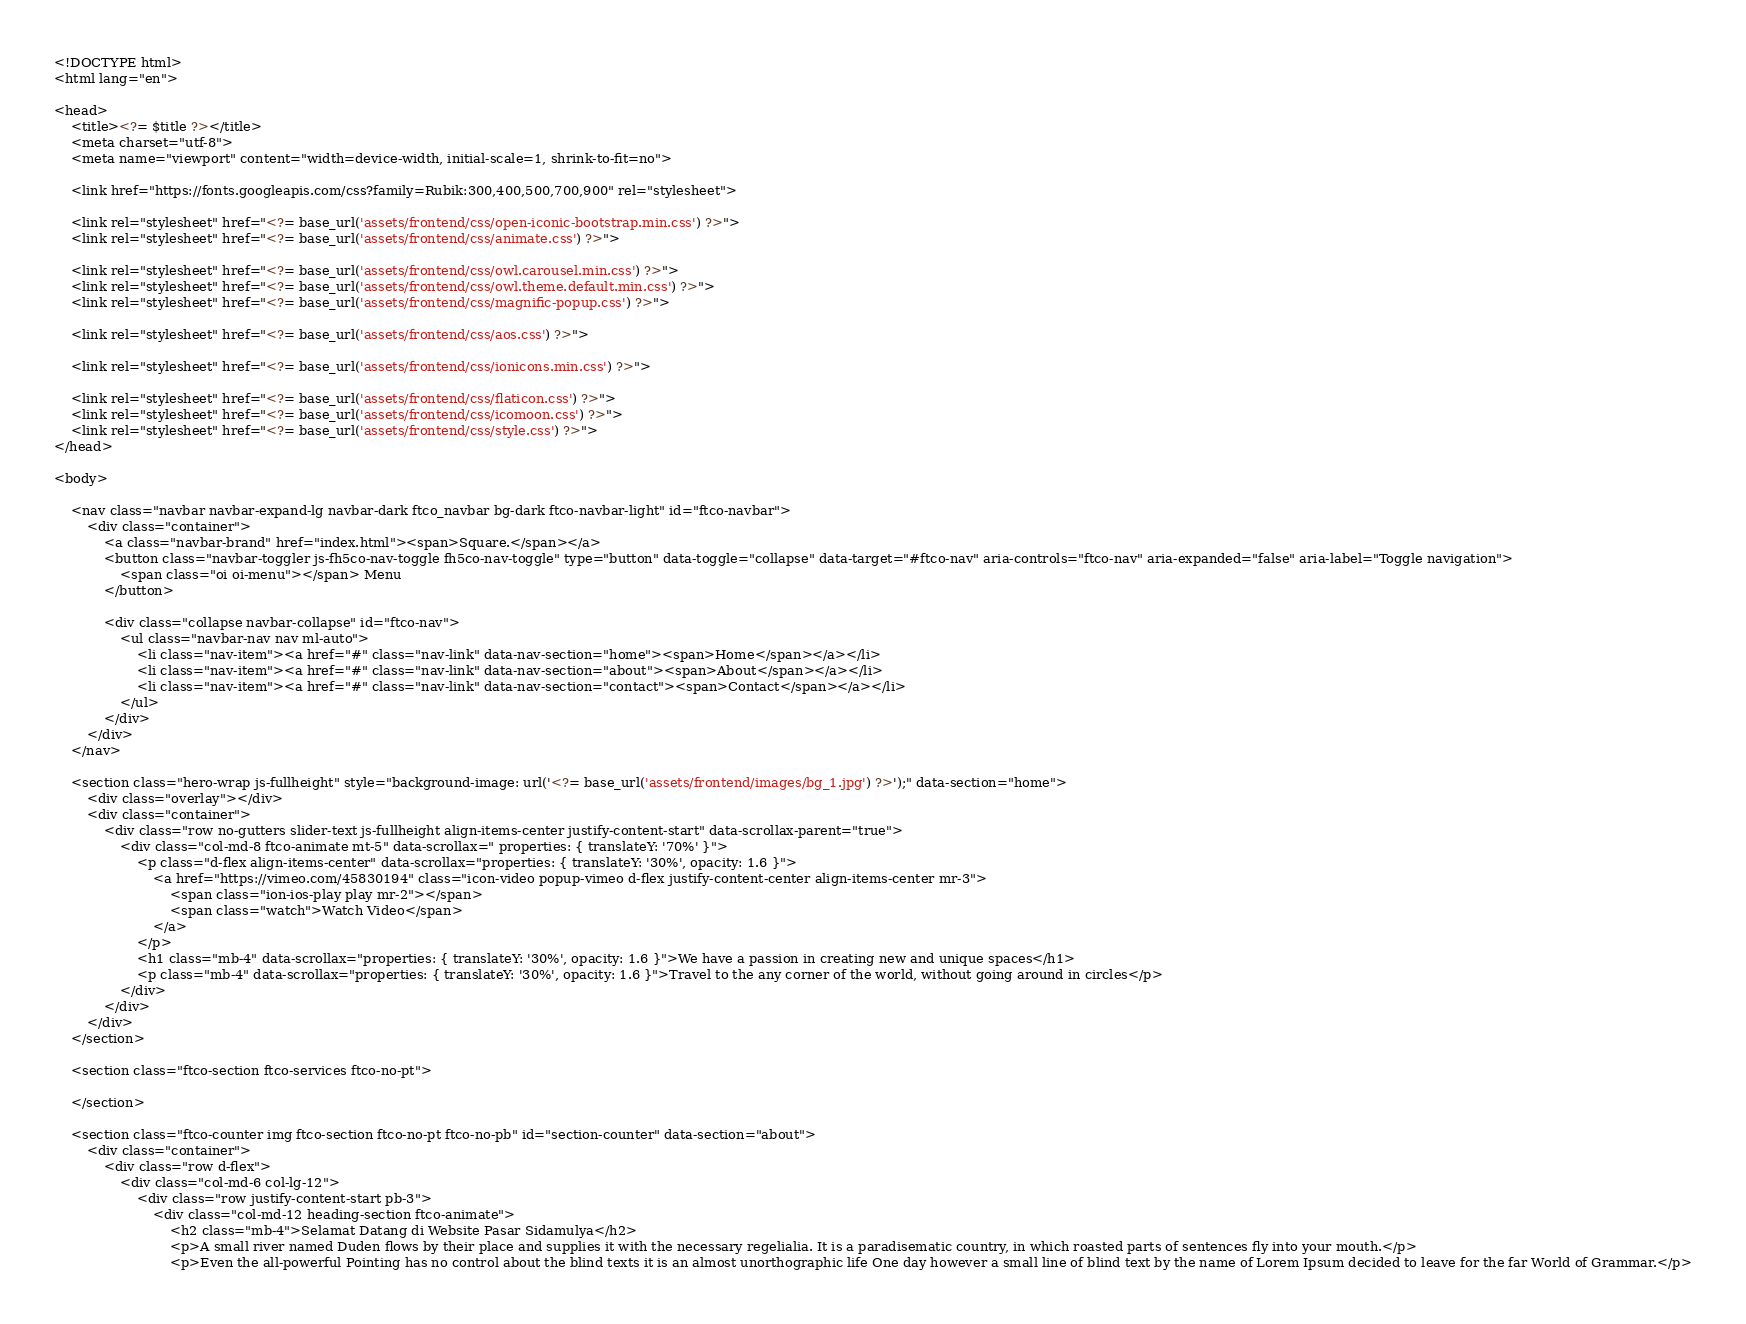Convert code to text. <code><loc_0><loc_0><loc_500><loc_500><_PHP_><!DOCTYPE html>
<html lang="en">

<head>
	<title><?= $title ?></title>
	<meta charset="utf-8">
	<meta name="viewport" content="width=device-width, initial-scale=1, shrink-to-fit=no">

	<link href="https://fonts.googleapis.com/css?family=Rubik:300,400,500,700,900" rel="stylesheet">

	<link rel="stylesheet" href="<?= base_url('assets/frontend/css/open-iconic-bootstrap.min.css') ?>">
	<link rel="stylesheet" href="<?= base_url('assets/frontend/css/animate.css') ?>">

	<link rel="stylesheet" href="<?= base_url('assets/frontend/css/owl.carousel.min.css') ?>">
	<link rel="stylesheet" href="<?= base_url('assets/frontend/css/owl.theme.default.min.css') ?>">
	<link rel="stylesheet" href="<?= base_url('assets/frontend/css/magnific-popup.css') ?>">

	<link rel="stylesheet" href="<?= base_url('assets/frontend/css/aos.css') ?>">

	<link rel="stylesheet" href="<?= base_url('assets/frontend/css/ionicons.min.css') ?>">

	<link rel="stylesheet" href="<?= base_url('assets/frontend/css/flaticon.css') ?>">
	<link rel="stylesheet" href="<?= base_url('assets/frontend/css/icomoon.css') ?>">
	<link rel="stylesheet" href="<?= base_url('assets/frontend/css/style.css') ?>">
</head>

<body>

	<nav class="navbar navbar-expand-lg navbar-dark ftco_navbar bg-dark ftco-navbar-light" id="ftco-navbar">
		<div class="container">
			<a class="navbar-brand" href="index.html"><span>Square.</span></a>
			<button class="navbar-toggler js-fh5co-nav-toggle fh5co-nav-toggle" type="button" data-toggle="collapse" data-target="#ftco-nav" aria-controls="ftco-nav" aria-expanded="false" aria-label="Toggle navigation">
				<span class="oi oi-menu"></span> Menu
			</button>

			<div class="collapse navbar-collapse" id="ftco-nav">
				<ul class="navbar-nav nav ml-auto">
					<li class="nav-item"><a href="#" class="nav-link" data-nav-section="home"><span>Home</span></a></li>
					<li class="nav-item"><a href="#" class="nav-link" data-nav-section="about"><span>About</span></a></li>
					<li class="nav-item"><a href="#" class="nav-link" data-nav-section="contact"><span>Contact</span></a></li>
				</ul>
			</div>
		</div>
	</nav>

	<section class="hero-wrap js-fullheight" style="background-image: url('<?= base_url('assets/frontend/images/bg_1.jpg') ?>');" data-section="home">
		<div class="overlay"></div>
		<div class="container">
			<div class="row no-gutters slider-text js-fullheight align-items-center justify-content-start" data-scrollax-parent="true">
				<div class="col-md-8 ftco-animate mt-5" data-scrollax=" properties: { translateY: '70%' }">
					<p class="d-flex align-items-center" data-scrollax="properties: { translateY: '30%', opacity: 1.6 }">
						<a href="https://vimeo.com/45830194" class="icon-video popup-vimeo d-flex justify-content-center align-items-center mr-3">
							<span class="ion-ios-play play mr-2"></span>
							<span class="watch">Watch Video</span>
						</a>
					</p>
					<h1 class="mb-4" data-scrollax="properties: { translateY: '30%', opacity: 1.6 }">We have a passion in creating new and unique spaces</h1>
					<p class="mb-4" data-scrollax="properties: { translateY: '30%', opacity: 1.6 }">Travel to the any corner of the world, without going around in circles</p>
				</div>
			</div>
		</div>
	</section>

	<section class="ftco-section ftco-services ftco-no-pt">

	</section>

	<section class="ftco-counter img ftco-section ftco-no-pt ftco-no-pb" id="section-counter" data-section="about">
		<div class="container">
			<div class="row d-flex">
				<div class="col-md-6 col-lg-12">
					<div class="row justify-content-start pb-3">
						<div class="col-md-12 heading-section ftco-animate">
							<h2 class="mb-4">Selamat Datang di Website Pasar Sidamulya</h2>
							<p>A small river named Duden flows by their place and supplies it with the necessary regelialia. It is a paradisematic country, in which roasted parts of sentences fly into your mouth.</p>
							<p>Even the all-powerful Pointing has no control about the blind texts it is an almost unorthographic life One day however a small line of blind text by the name of Lorem Ipsum decided to leave for the far World of Grammar.</p></code> 